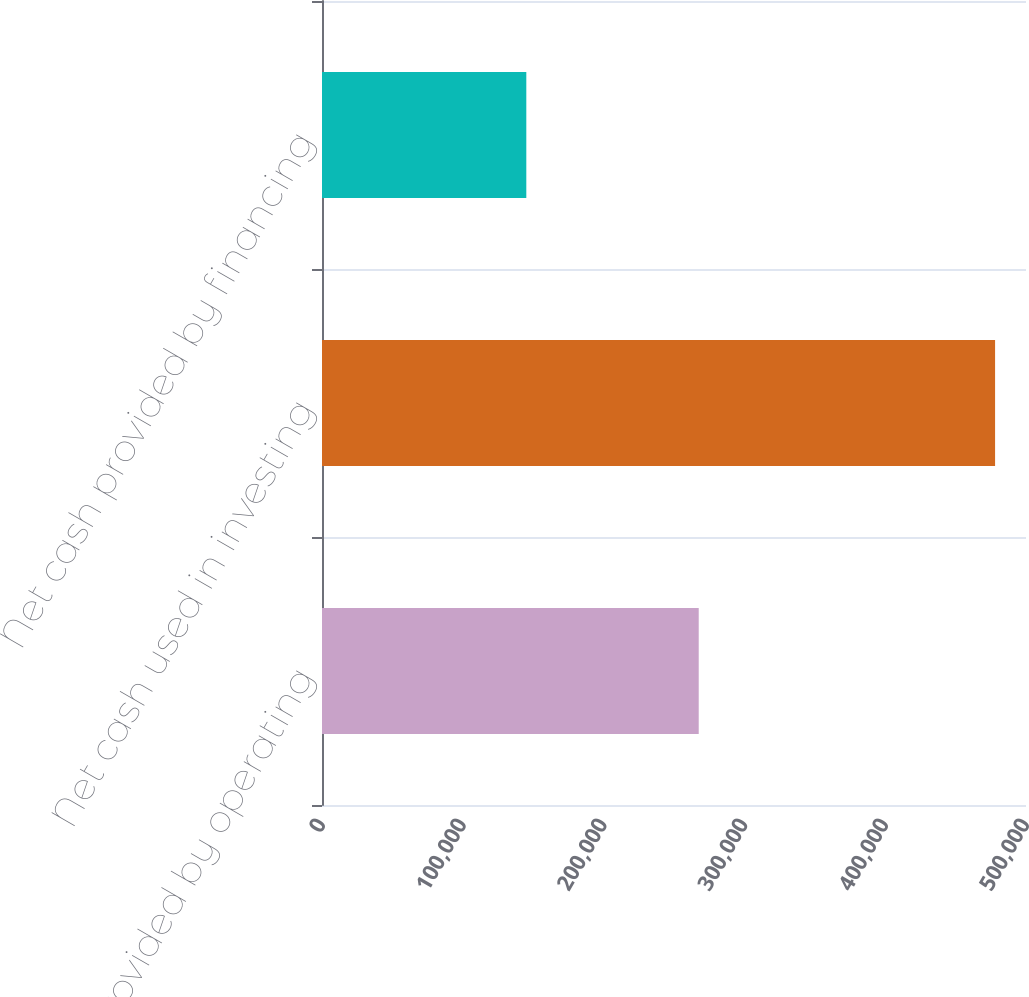<chart> <loc_0><loc_0><loc_500><loc_500><bar_chart><fcel>Net cash provided by operating<fcel>Net cash used in investing<fcel>Net cash provided by financing<nl><fcel>267558<fcel>478040<fcel>145106<nl></chart> 